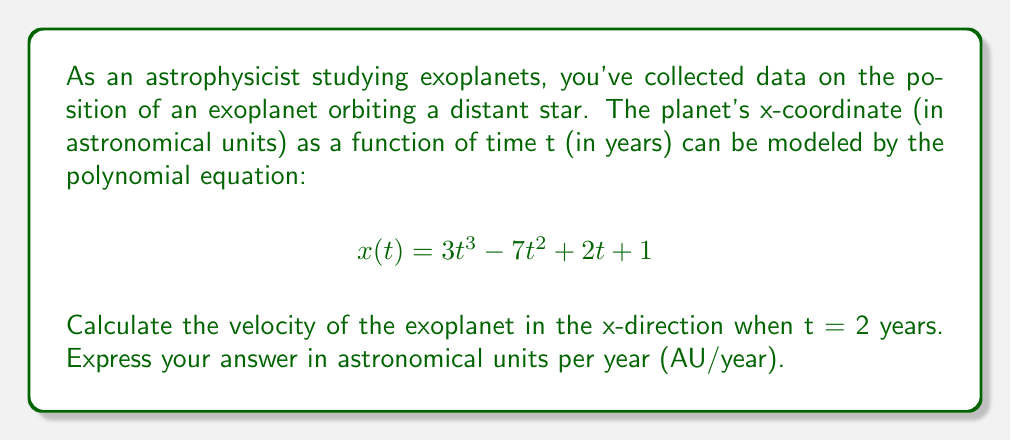Solve this math problem. To solve this problem, we need to follow these steps:

1) The velocity in the x-direction is given by the first derivative of the position function x(t) with respect to time.

2) Let's find the derivative of x(t):
   $$x(t) = 3t^3 - 7t^2 + 2t + 1$$
   $$\frac{dx}{dt} = 9t^2 - 14t + 2$$

3) This derivative function $\frac{dx}{dt}$ represents the velocity in the x-direction at any time t.

4) We need to find the velocity when t = 2 years. Let's substitute t = 2 into our velocity function:

   $$\frac{dx}{dt}\bigg|_{t=2} = 9(2)^2 - 14(2) + 2$$
   $$= 9(4) - 28 + 2$$
   $$= 36 - 28 + 2$$
   $$= 10$$

5) Therefore, the velocity in the x-direction when t = 2 years is 10 AU/year.

This result tells us that at t = 2 years, the exoplanet is moving in the positive x-direction at a rate of 10 astronomical units per year.
Answer: 10 AU/year 